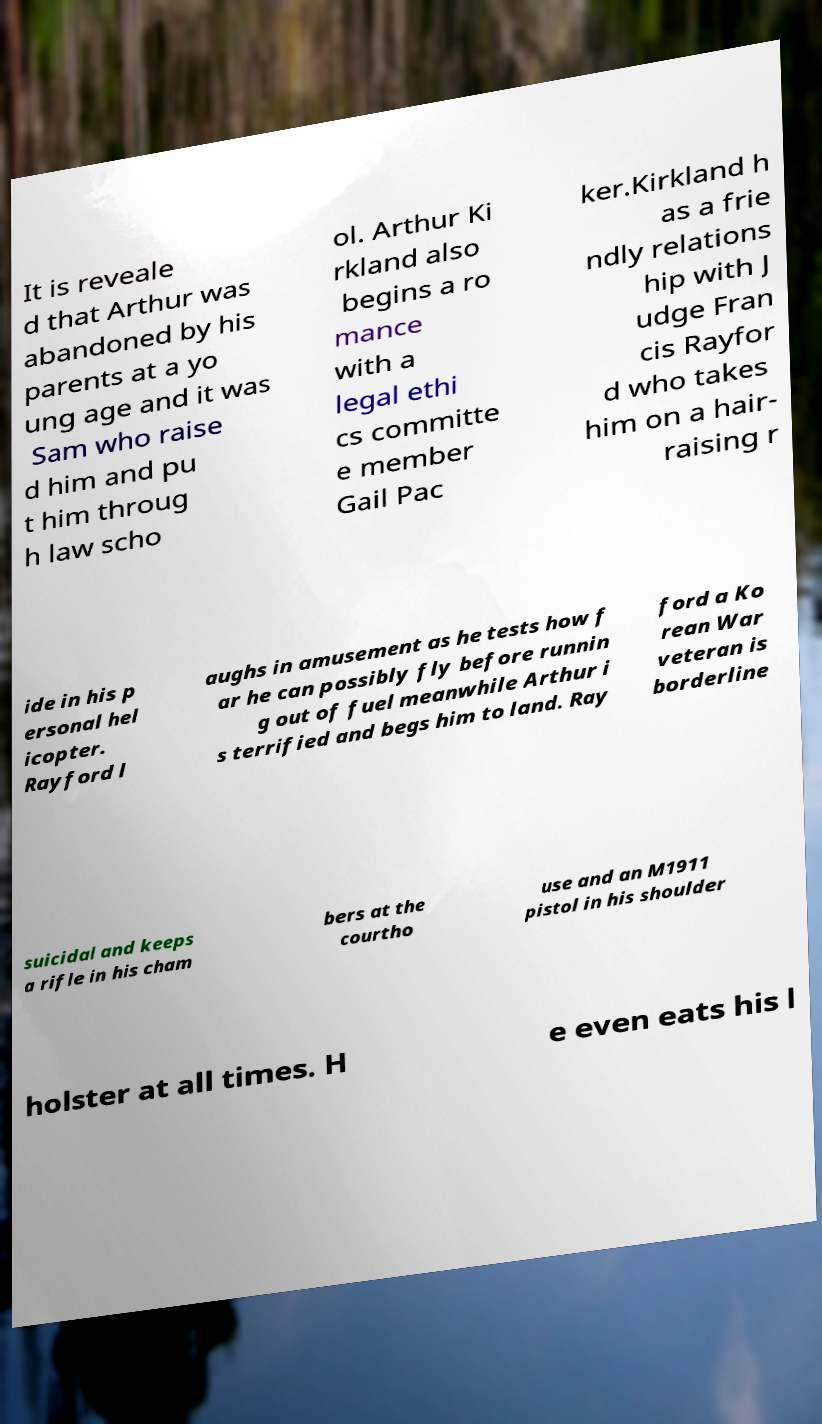There's text embedded in this image that I need extracted. Can you transcribe it verbatim? It is reveale d that Arthur was abandoned by his parents at a yo ung age and it was Sam who raise d him and pu t him throug h law scho ol. Arthur Ki rkland also begins a ro mance with a legal ethi cs committe e member Gail Pac ker.Kirkland h as a frie ndly relations hip with J udge Fran cis Rayfor d who takes him on a hair- raising r ide in his p ersonal hel icopter. Rayford l aughs in amusement as he tests how f ar he can possibly fly before runnin g out of fuel meanwhile Arthur i s terrified and begs him to land. Ray ford a Ko rean War veteran is borderline suicidal and keeps a rifle in his cham bers at the courtho use and an M1911 pistol in his shoulder holster at all times. H e even eats his l 